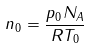Convert formula to latex. <formula><loc_0><loc_0><loc_500><loc_500>n _ { 0 } = \frac { p _ { 0 } N _ { A } } { R T _ { 0 } }</formula> 